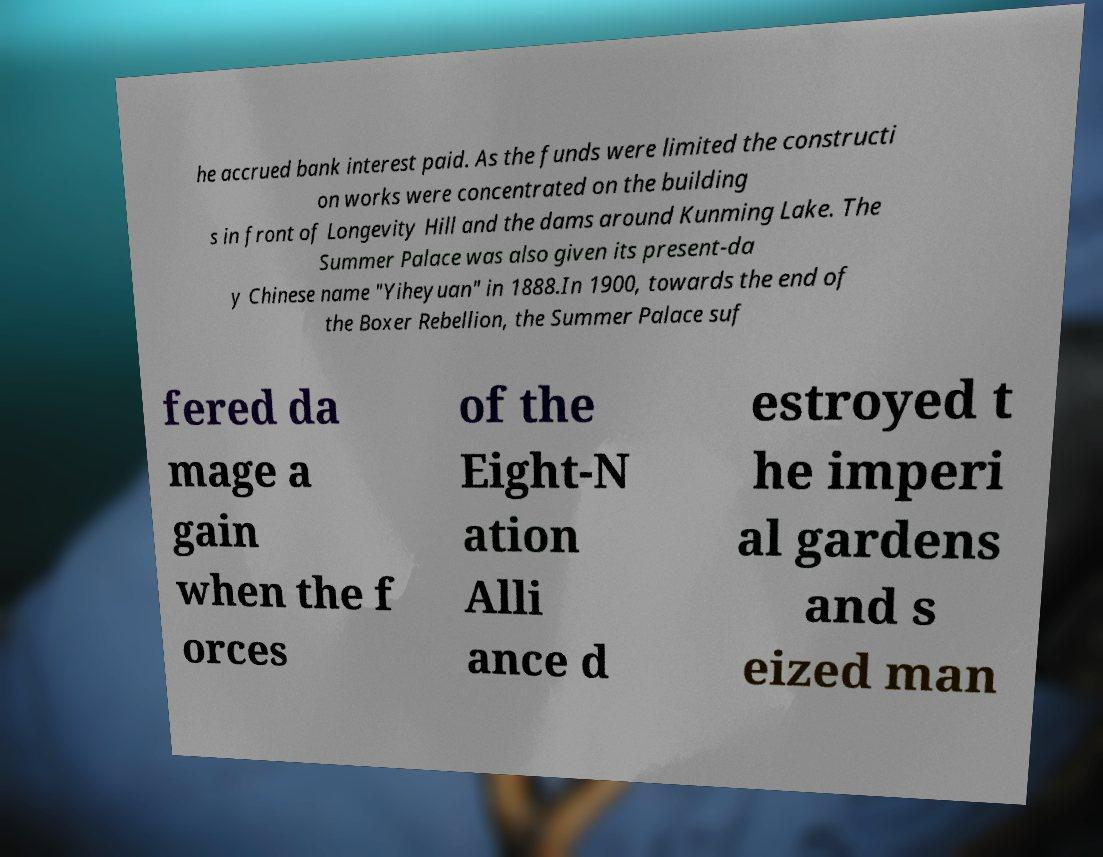For documentation purposes, I need the text within this image transcribed. Could you provide that? he accrued bank interest paid. As the funds were limited the constructi on works were concentrated on the building s in front of Longevity Hill and the dams around Kunming Lake. The Summer Palace was also given its present-da y Chinese name "Yiheyuan" in 1888.In 1900, towards the end of the Boxer Rebellion, the Summer Palace suf fered da mage a gain when the f orces of the Eight-N ation Alli ance d estroyed t he imperi al gardens and s eized man 